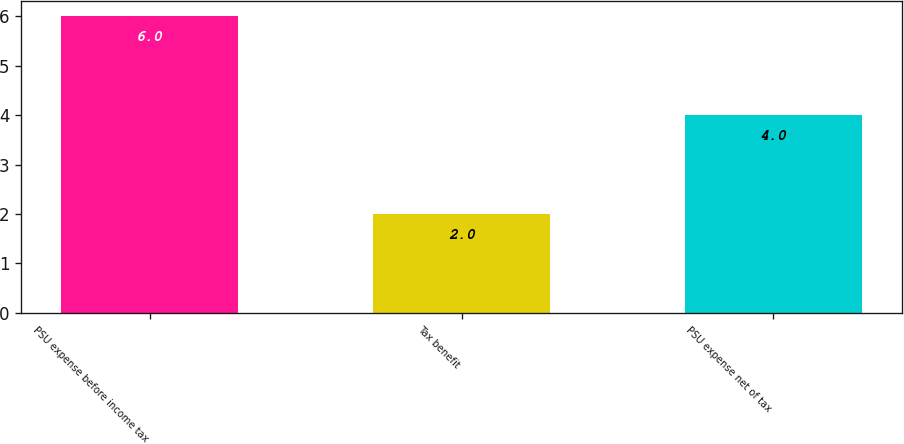Convert chart. <chart><loc_0><loc_0><loc_500><loc_500><bar_chart><fcel>PSU expense before income tax<fcel>Tax benefit<fcel>PSU expense net of tax<nl><fcel>6<fcel>2<fcel>4<nl></chart> 